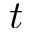<formula> <loc_0><loc_0><loc_500><loc_500>t</formula> 